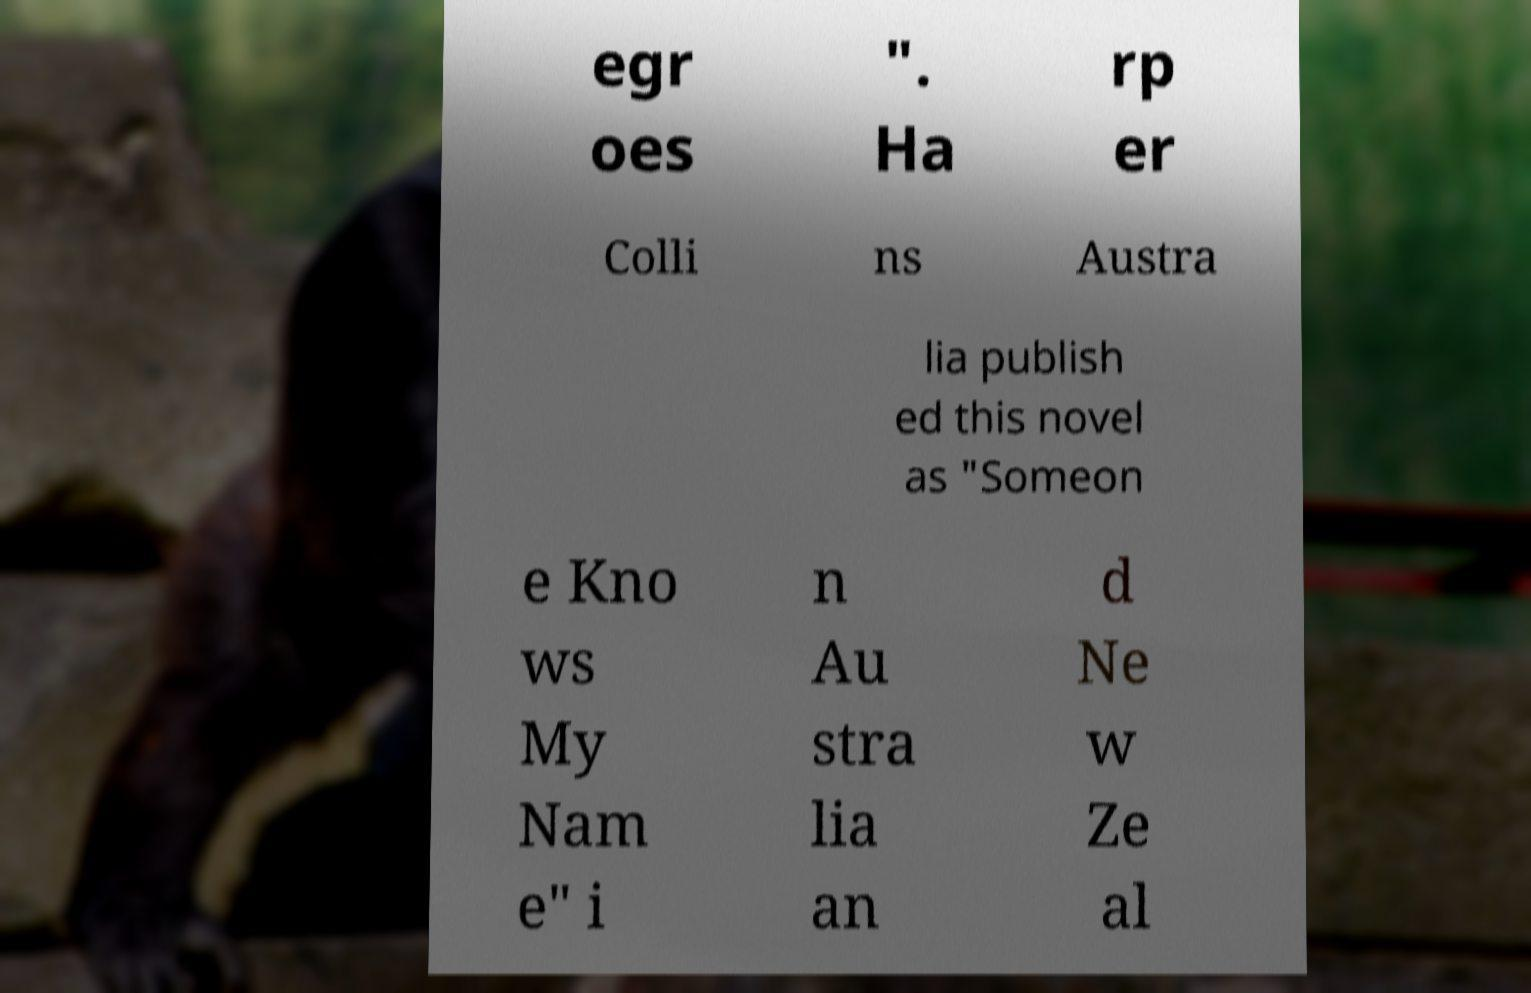Please identify and transcribe the text found in this image. egr oes ". Ha rp er Colli ns Austra lia publish ed this novel as "Someon e Kno ws My Nam e" i n Au stra lia an d Ne w Ze al 